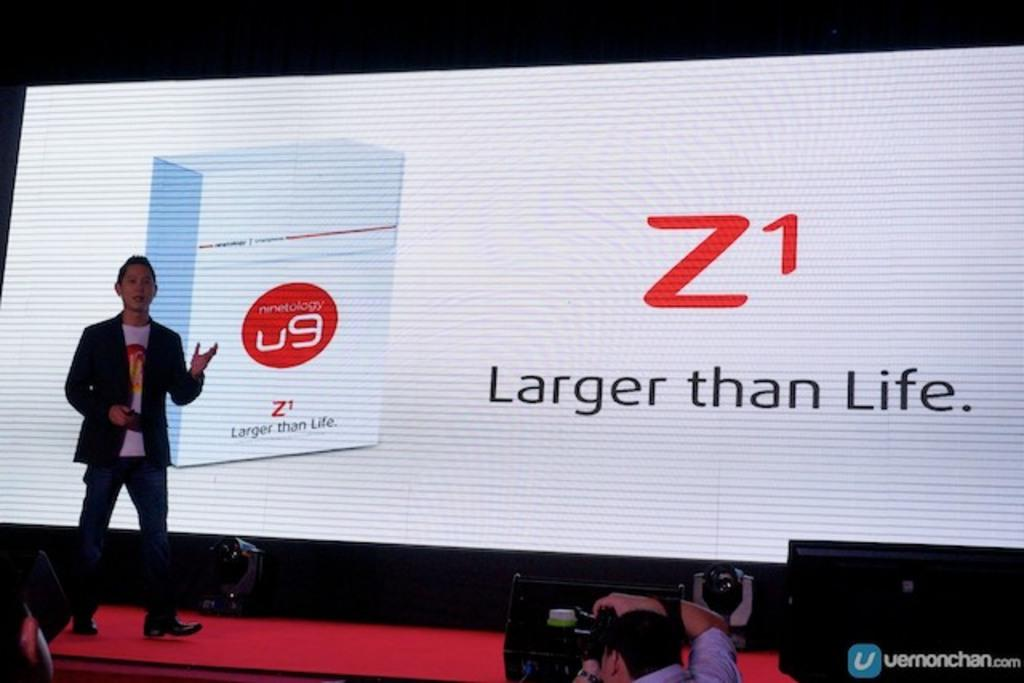What is the person in the image doing? The person is standing on a stage. What is on the wall behind the person? There is a screen on the wall behind the person. Who is in front of the person on the stage? There are people in front of the person. What are some of the people in front of the person doing? Some of the people in front of the person are using cameras. What type of scarf is the robin wearing in the image? There is no robin or scarf present in the image. 